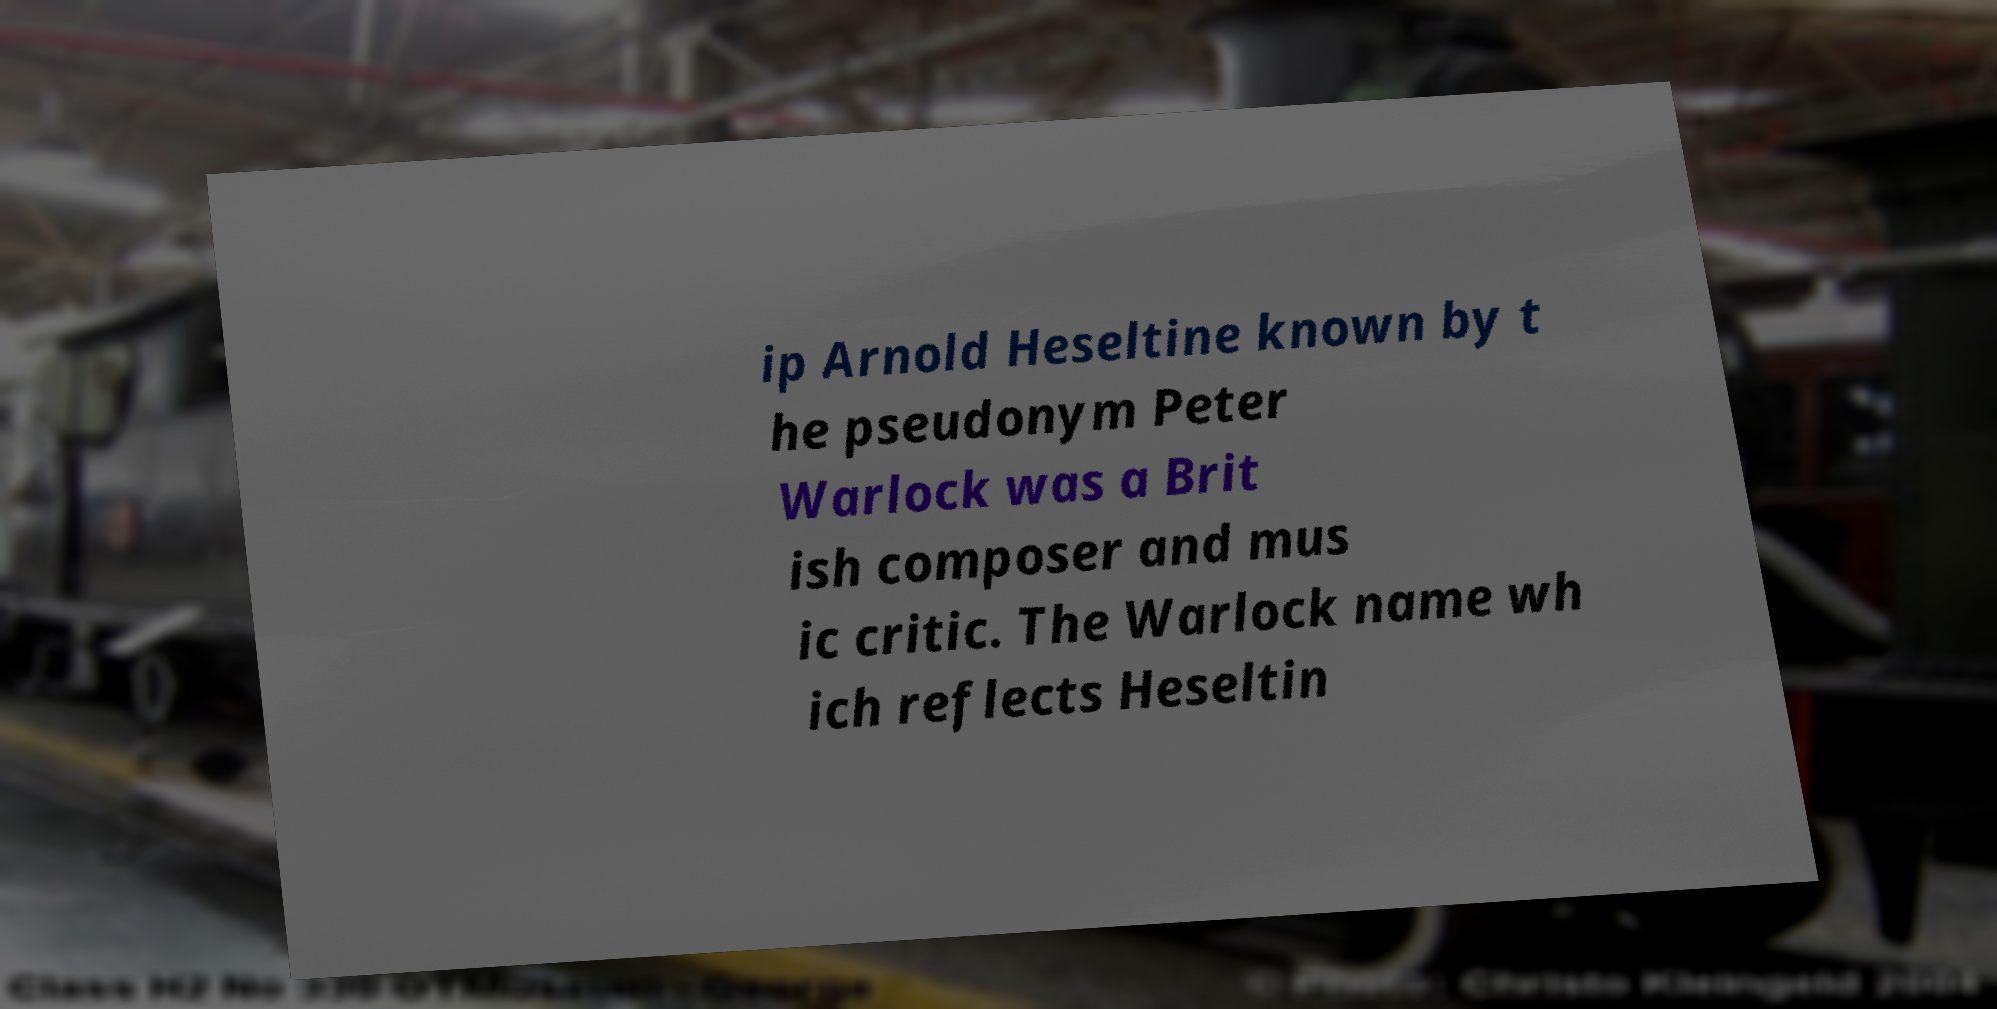Please read and relay the text visible in this image. What does it say? ip Arnold Heseltine known by t he pseudonym Peter Warlock was a Brit ish composer and mus ic critic. The Warlock name wh ich reflects Heseltin 